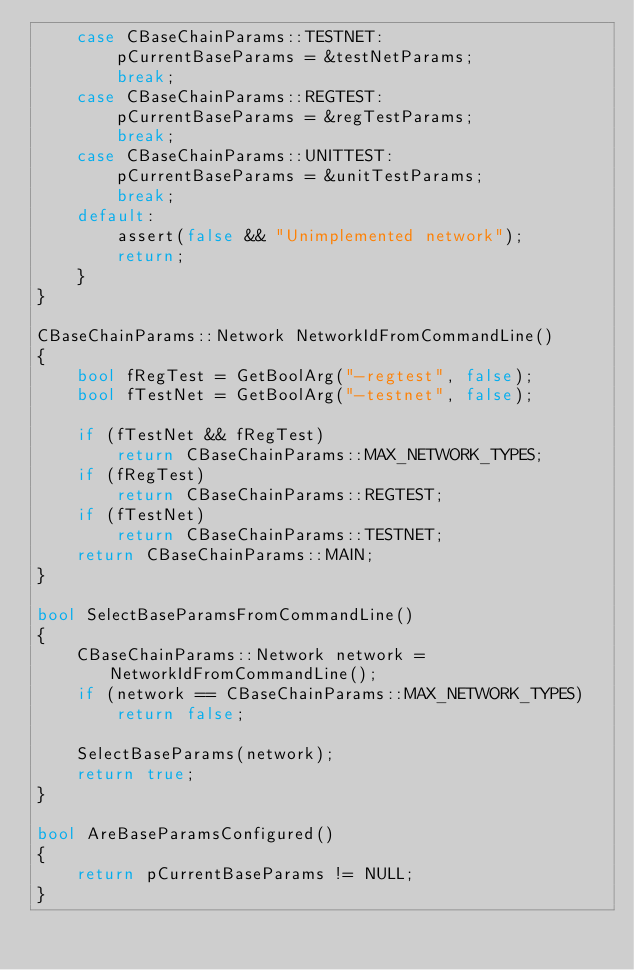<code> <loc_0><loc_0><loc_500><loc_500><_C++_>    case CBaseChainParams::TESTNET:
        pCurrentBaseParams = &testNetParams;
        break;
    case CBaseChainParams::REGTEST:
        pCurrentBaseParams = &regTestParams;
        break;
    case CBaseChainParams::UNITTEST:
        pCurrentBaseParams = &unitTestParams;
        break;
    default:
        assert(false && "Unimplemented network");
        return;
    }
}

CBaseChainParams::Network NetworkIdFromCommandLine()
{
    bool fRegTest = GetBoolArg("-regtest", false);
    bool fTestNet = GetBoolArg("-testnet", false);

    if (fTestNet && fRegTest)
        return CBaseChainParams::MAX_NETWORK_TYPES;
    if (fRegTest)
        return CBaseChainParams::REGTEST;
    if (fTestNet)
        return CBaseChainParams::TESTNET;
    return CBaseChainParams::MAIN;
}

bool SelectBaseParamsFromCommandLine()
{
    CBaseChainParams::Network network = NetworkIdFromCommandLine();
    if (network == CBaseChainParams::MAX_NETWORK_TYPES)
        return false;

    SelectBaseParams(network);
    return true;
}

bool AreBaseParamsConfigured()
{
    return pCurrentBaseParams != NULL;
}
</code> 